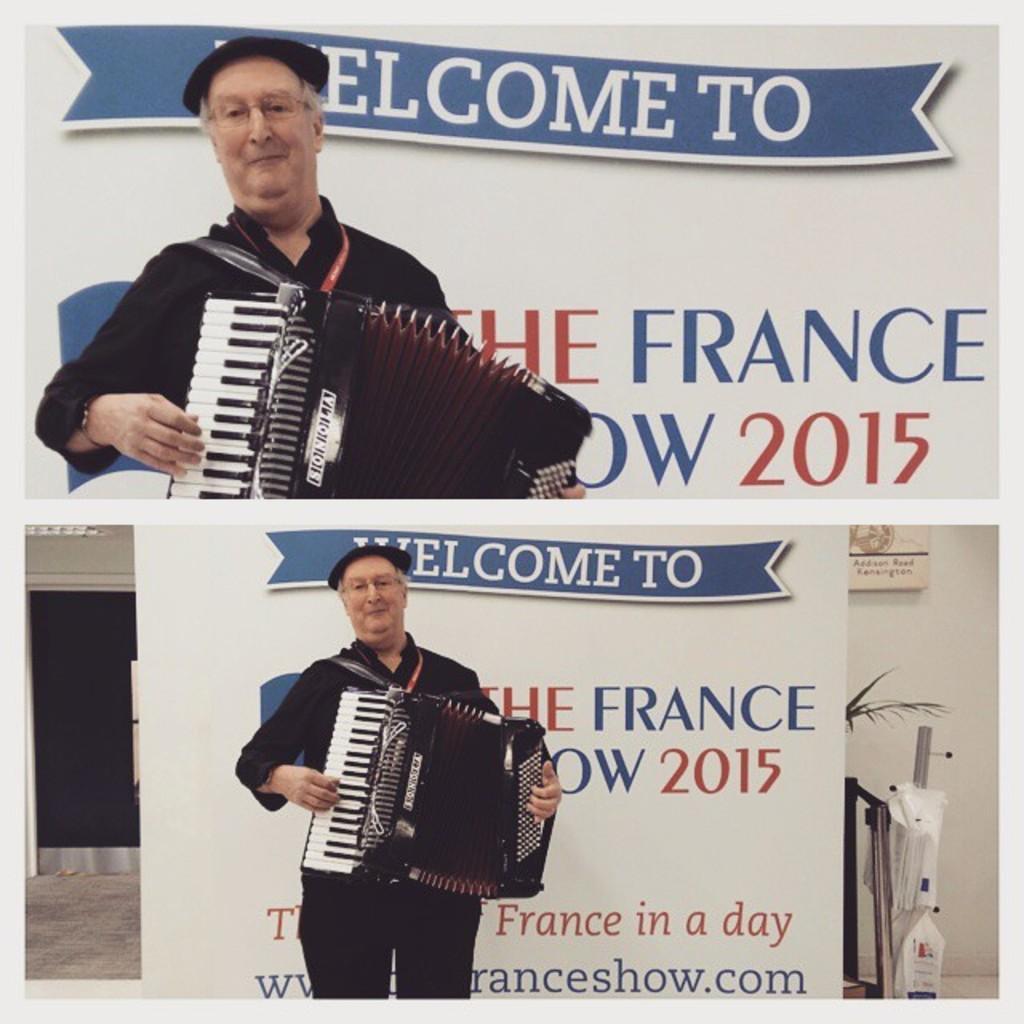Could you give a brief overview of what you see in this image? In this image I can see a man is standing and holding an musical instrument in hands. In the background I can see a board on which something written on it and other objects on the ground. 